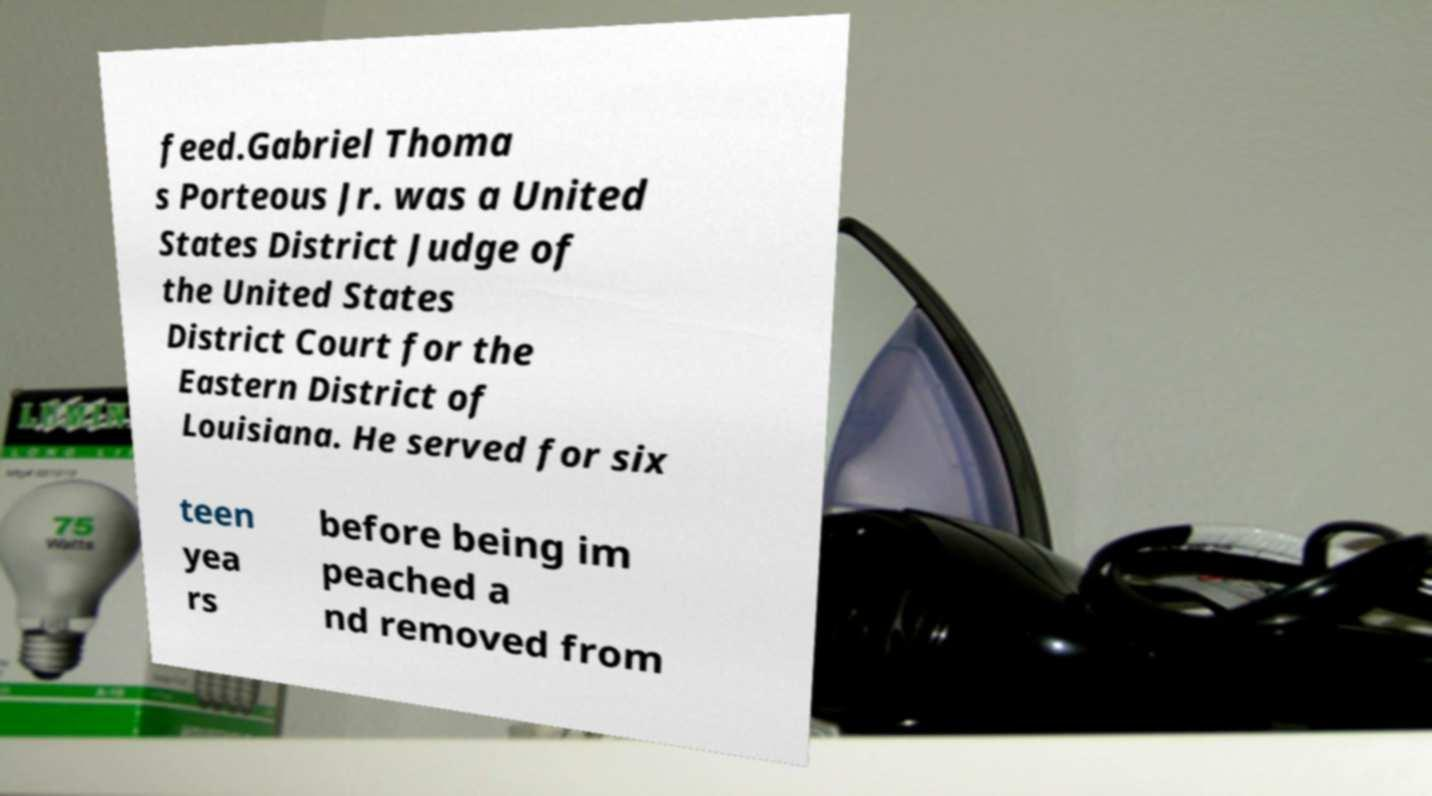Can you read and provide the text displayed in the image?This photo seems to have some interesting text. Can you extract and type it out for me? feed.Gabriel Thoma s Porteous Jr. was a United States District Judge of the United States District Court for the Eastern District of Louisiana. He served for six teen yea rs before being im peached a nd removed from 